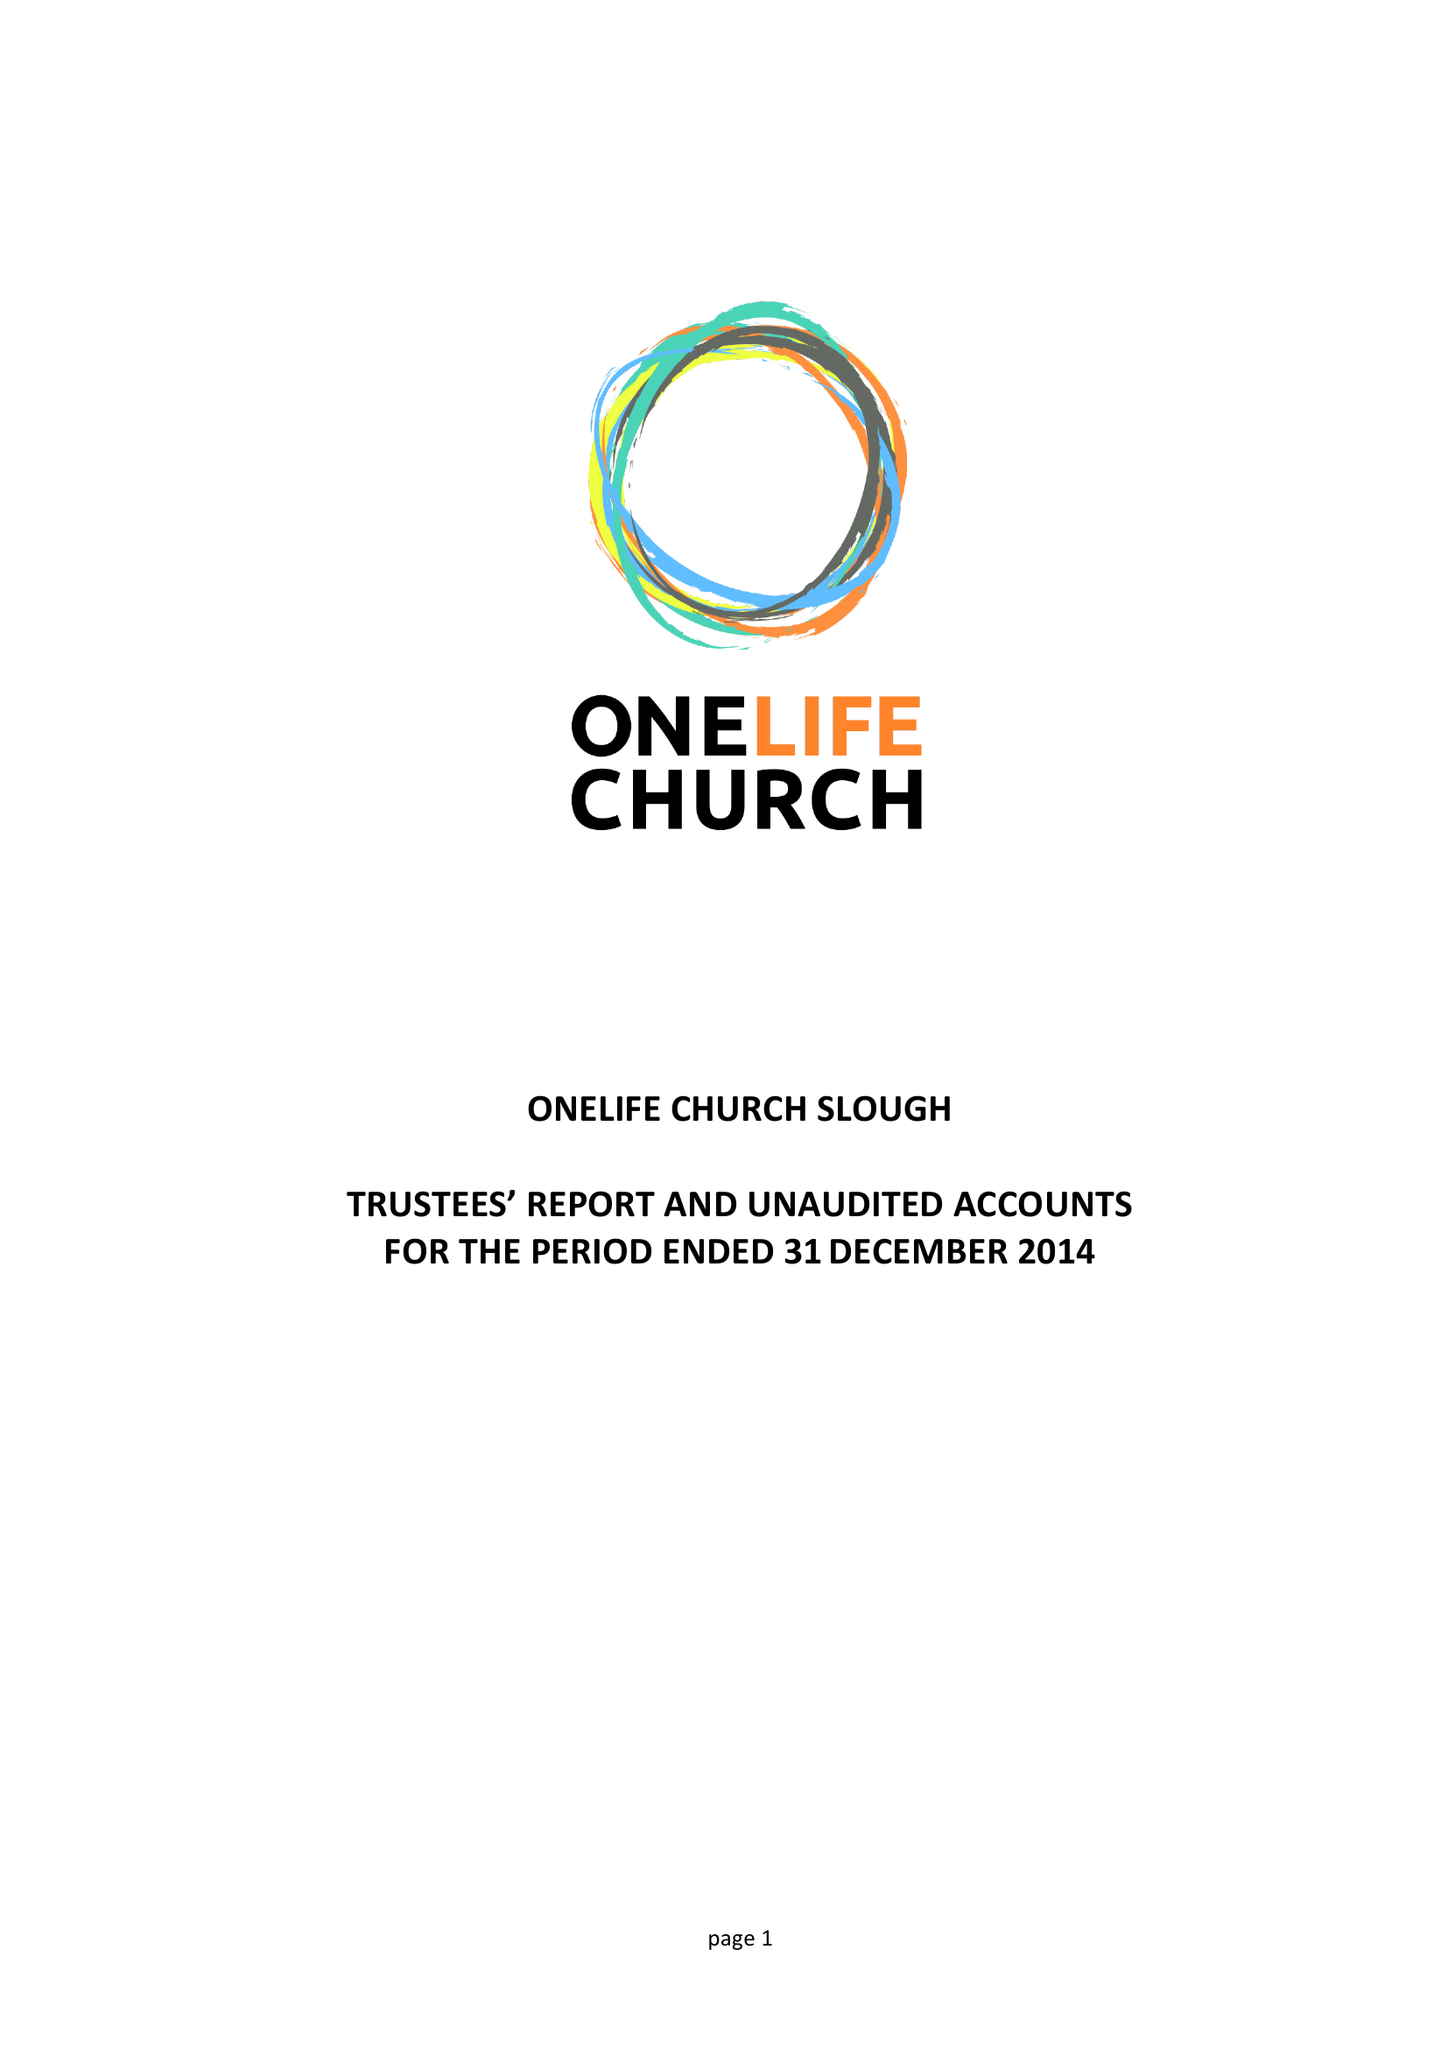What is the value for the address__postcode?
Answer the question using a single word or phrase. SL2 1TY 